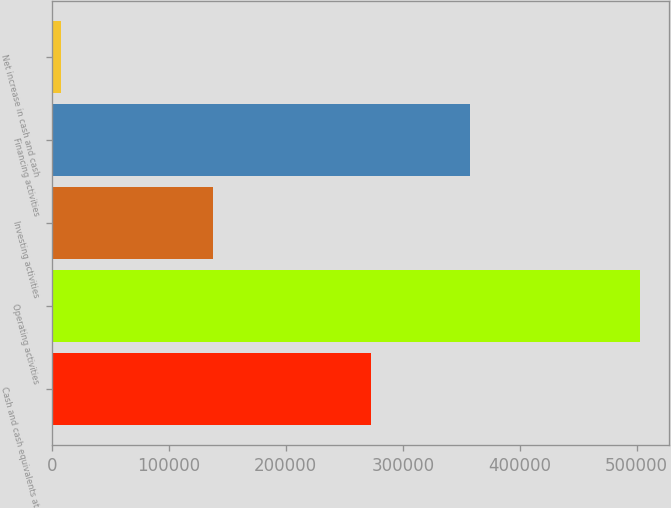Convert chart. <chart><loc_0><loc_0><loc_500><loc_500><bar_chart><fcel>Cash and cash equivalents at<fcel>Operating activities<fcel>Investing activities<fcel>Financing activities<fcel>Net increase in cash and cash<nl><fcel>272684<fcel>502536<fcel>137562<fcel>357492<fcel>7482<nl></chart> 